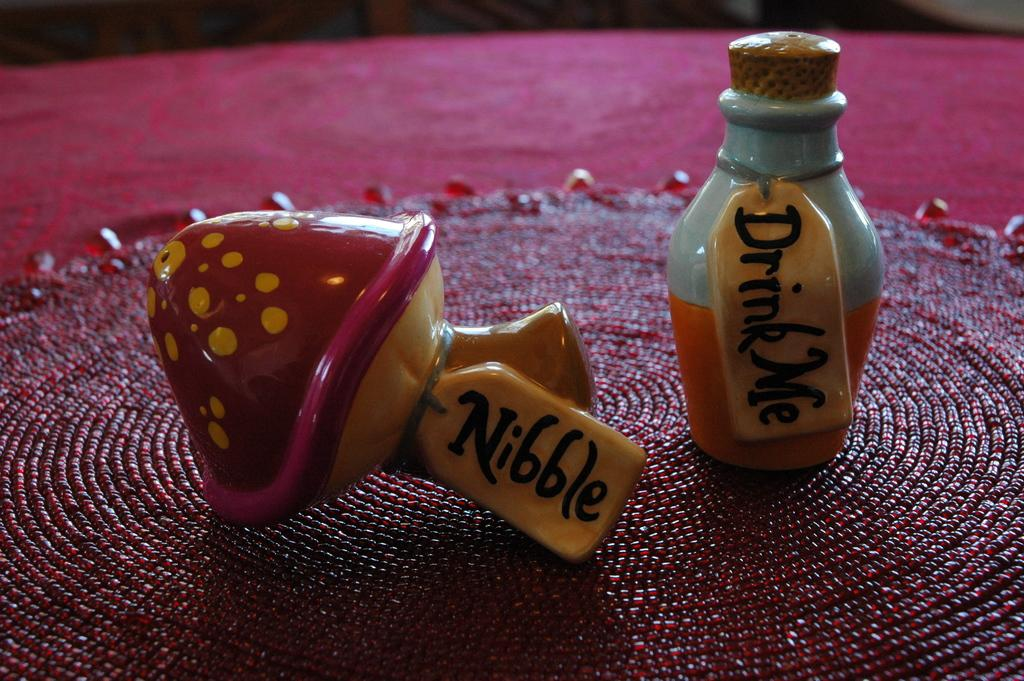<image>
Give a short and clear explanation of the subsequent image. a little statue with the word nibble on it 